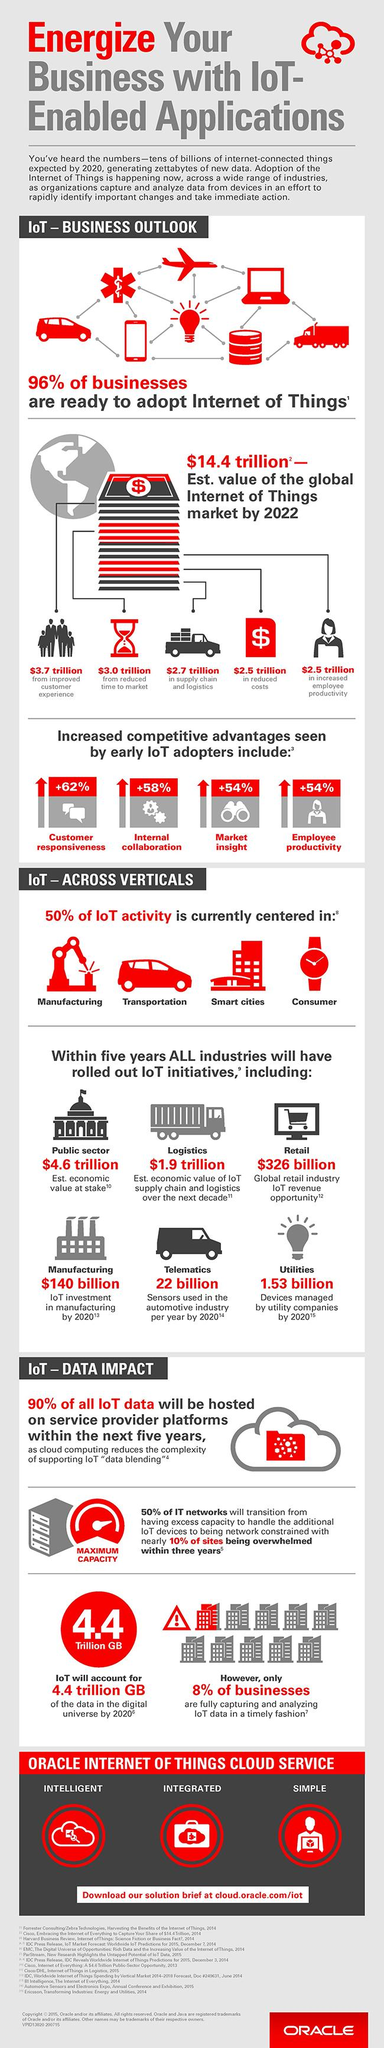Specify some key components in this picture. The percentage increase in customer responsiveness due to IoT is +62%. According to a recent estimate, the IoT revenue opportunity in the global retail industry is expected to reach $326 billion by 2026. 